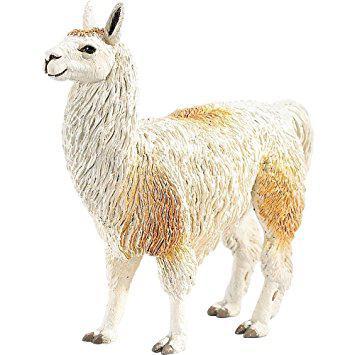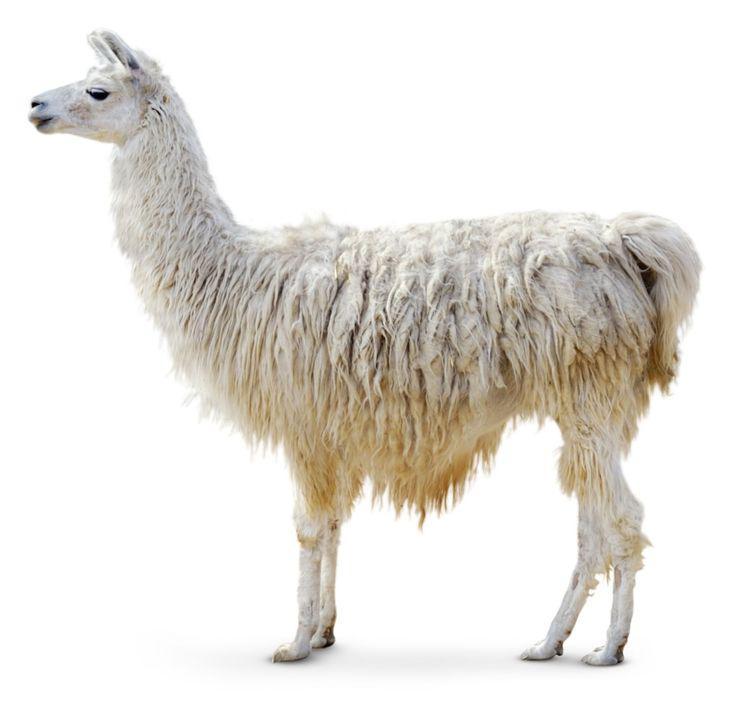The first image is the image on the left, the second image is the image on the right. Given the left and right images, does the statement "There are exactly three llamas." hold true? Answer yes or no. No. The first image is the image on the left, the second image is the image on the right. Analyze the images presented: Is the assertion "Each image shows a single llama figure, which is standing in profile facing leftward." valid? Answer yes or no. Yes. 